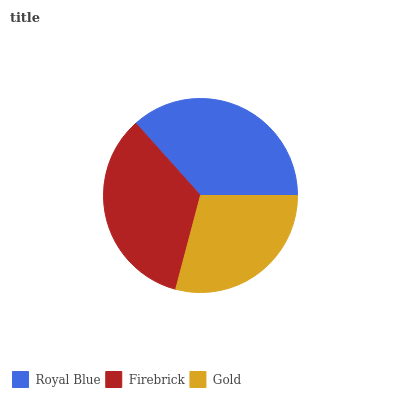Is Gold the minimum?
Answer yes or no. Yes. Is Royal Blue the maximum?
Answer yes or no. Yes. Is Firebrick the minimum?
Answer yes or no. No. Is Firebrick the maximum?
Answer yes or no. No. Is Royal Blue greater than Firebrick?
Answer yes or no. Yes. Is Firebrick less than Royal Blue?
Answer yes or no. Yes. Is Firebrick greater than Royal Blue?
Answer yes or no. No. Is Royal Blue less than Firebrick?
Answer yes or no. No. Is Firebrick the high median?
Answer yes or no. Yes. Is Firebrick the low median?
Answer yes or no. Yes. Is Royal Blue the high median?
Answer yes or no. No. Is Royal Blue the low median?
Answer yes or no. No. 